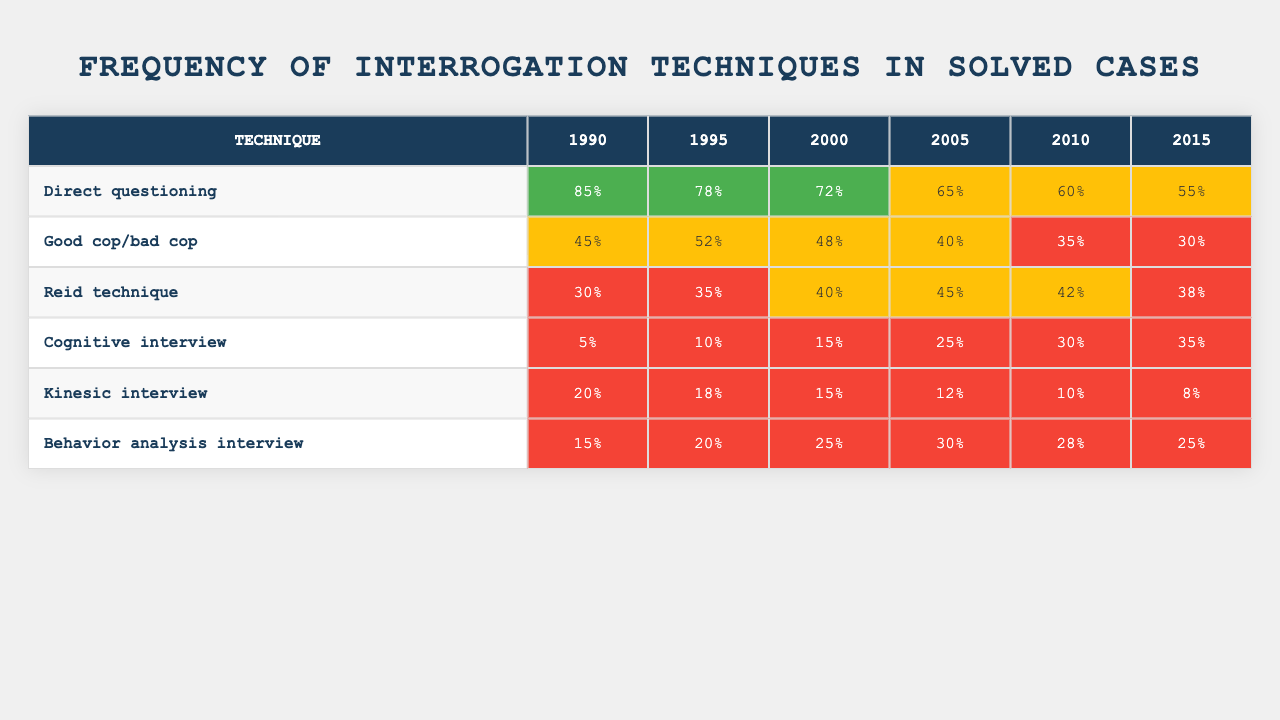What interrogation technique had the highest frequency in 1990? By looking at the first column for 1990, we see that "Direct questioning" has the frequency of 85%, which is the highest compared to other techniques.
Answer: Direct questioning What was the frequency of the "Cognitive interview" technique in 2015? The last column for "Cognitive interview" shows a frequency of 35% for the year 2015.
Answer: 35% Which technique showed a downward trend from 1990 to 2015? By comparing the frequencies for each year for all techniques, "Good cop/bad cop" frequency decreased from 45% in 1990 to 30% in 2015, indicating a downward trend.
Answer: Good cop/bad cop What is the average frequency of the "Reid technique" from 1990 to 2015? The frequencies for the "Reid technique" are 30%, 35%, 40%, 45%, 42%, and 38% respectively. The sum is 30 + 35 + 40 + 45 + 42 + 38 = 230. There are 6 data points; thus, the average is 230/6 ≈ 38.33%.
Answer: 38.33% Is the frequency of "Kinesic interview" higher in 2000 than in 2005? The frequency for "Kinesic interview" is 15% in 2005 and 20% in 2000, indicating that the frequency in 2000 is higher than in 2005.
Answer: Yes Which technique had the lowest frequency in 2010? In 2010, "Kinesic interview" has the lowest frequency at 10% compared to the frequencies of other techniques for that year.
Answer: Kinesic interview What is the total frequency of "Behavior analysis interview" across all years? The frequencies for "Behavior analysis interview" are 15%, 20%, 25%, 30%, 28%, and 25%. Adding these gives a total of 15 + 20 + 25 + 30 + 28 + 25 = 143%.
Answer: 143% What was the frequency difference between "Direct questioning" in 1990 and "Cognitive interview" in 2015? The frequency for "Direct questioning" in 1990 is 85% and for "Cognitive interview" in 2015 is 35%. The difference is 85% - 35% = 50%.
Answer: 50% Which technique had the highest frequency in the year 2000? By checking the 2000 column, the highest frequency is 72% for "Direct questioning," which is higher than the other techniques.
Answer: Direct questioning Did any technique consistently increase in frequency from 1990 to 2015? Looking at the data, "Cognitive interview" shows an increase from 5% in 1990 to 35% in 2015, which means it consistently increased over these years.
Answer: Yes 